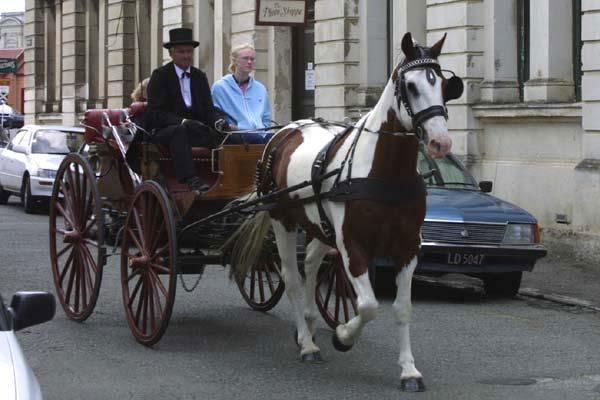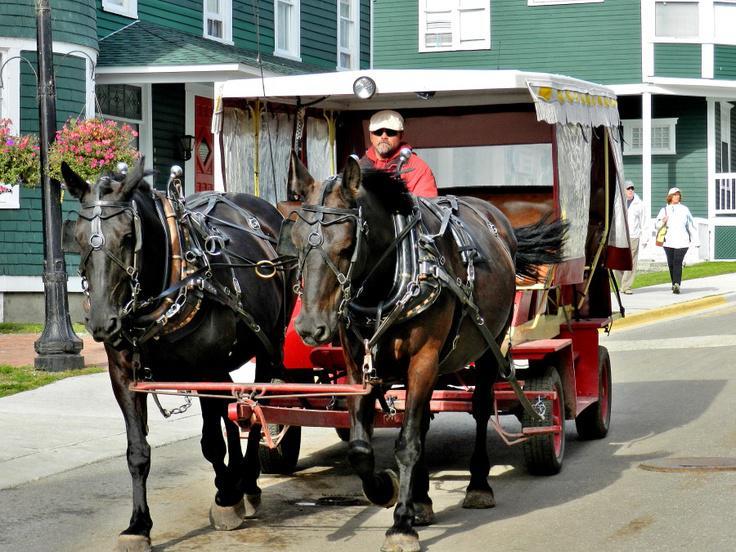The first image is the image on the left, the second image is the image on the right. Evaluate the accuracy of this statement regarding the images: "One image features a four-wheeled cart pulled by just one horse.". Is it true? Answer yes or no. Yes. The first image is the image on the left, the second image is the image on the right. For the images displayed, is the sentence "One of the images contains a white carriage." factually correct? Answer yes or no. No. 